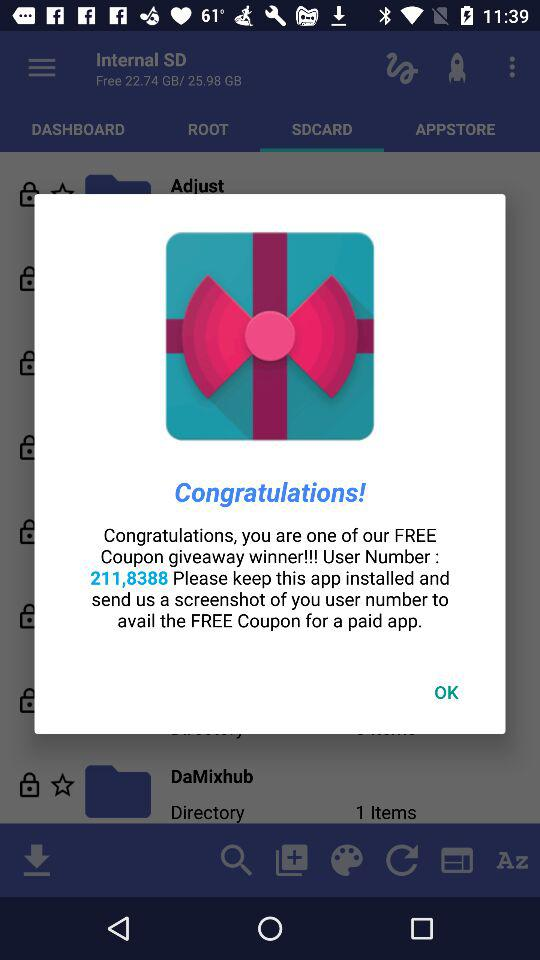What is the current number of items showing in the directory? The current number of items is 1. 